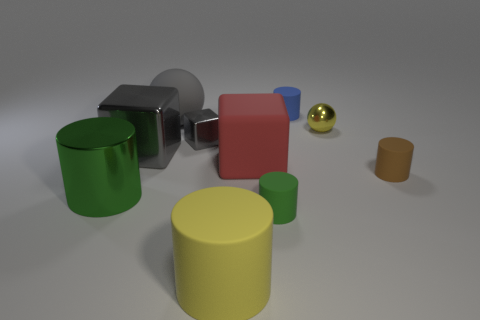The yellow ball that is made of the same material as the big green cylinder is what size?
Provide a short and direct response. Small. Does the ball left of the blue cylinder have the same size as the metallic thing that is on the right side of the green matte cylinder?
Offer a very short reply. No. How many things are either tiny blue things or big red matte blocks?
Offer a terse response. 2. What shape is the large yellow object?
Your answer should be very brief. Cylinder. What size is the green shiny object that is the same shape as the small brown rubber thing?
Make the answer very short. Large. There is a yellow object that is left of the small rubber cylinder that is behind the brown thing; what is its size?
Offer a terse response. Large. Are there the same number of matte objects behind the big yellow rubber cylinder and purple rubber cylinders?
Make the answer very short. No. How many other objects are the same color as the rubber cube?
Give a very brief answer. 0. Is the number of large metal objects behind the tiny gray object less than the number of small green rubber things?
Offer a very short reply. Yes. Are there any other cylinders of the same size as the blue rubber cylinder?
Your answer should be very brief. Yes. 